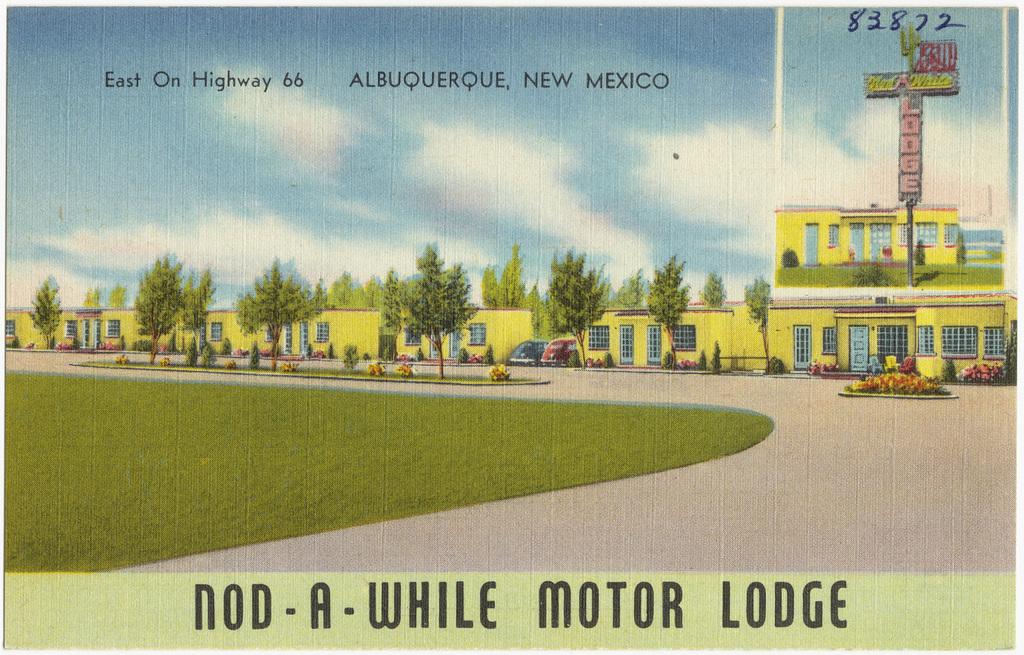What is the name of the motor ledge?
Provide a short and direct response. Nod-a-while. 